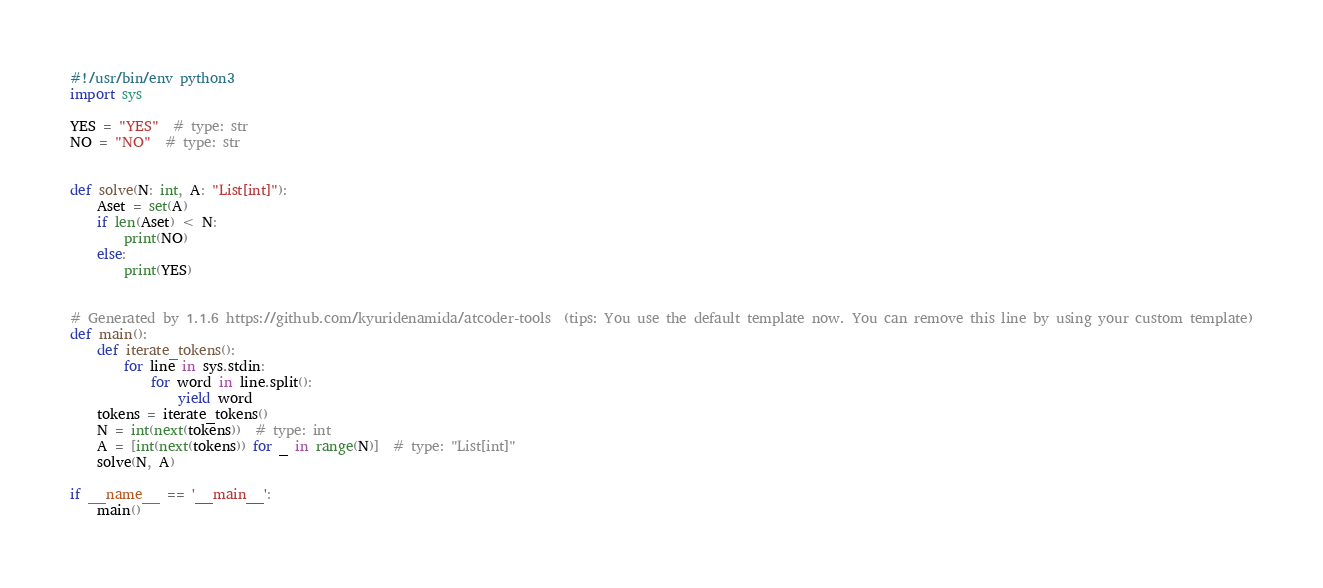Convert code to text. <code><loc_0><loc_0><loc_500><loc_500><_Python_>#!/usr/bin/env python3
import sys

YES = "YES"  # type: str
NO = "NO"  # type: str


def solve(N: int, A: "List[int]"):
    Aset = set(A)
    if len(Aset) < N:
        print(NO)
    else:
        print(YES)


# Generated by 1.1.6 https://github.com/kyuridenamida/atcoder-tools  (tips: You use the default template now. You can remove this line by using your custom template)
def main():
    def iterate_tokens():
        for line in sys.stdin:
            for word in line.split():
                yield word
    tokens = iterate_tokens()
    N = int(next(tokens))  # type: int
    A = [int(next(tokens)) for _ in range(N)]  # type: "List[int]"
    solve(N, A)

if __name__ == '__main__':
    main()
</code> 